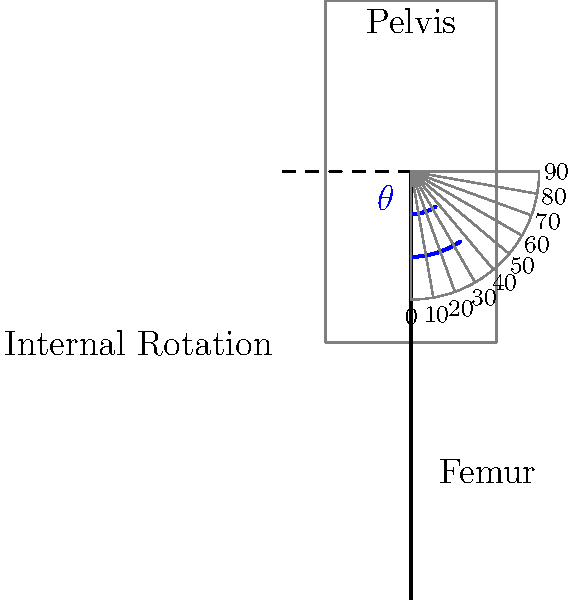In the skeletal diagram provided, the femur is shown internally rotated from its neutral position. Using the protractor overlay, determine the precise angle $\theta$ of hip internal rotation. What is the physiological significance of this measurement in assessing hip joint function and potential pathologies? To accurately measure the angle of hip internal rotation, we'll follow these steps:

1. Identify the neutral position: In a neutral hip position, the femur would be perpendicular to the transverse plane of the pelvis, which is represented by the horizontal dashed line.

2. Locate the current position: The solid line representing the femur shows its position after internal rotation.

3. Measure the angle: The angle $\theta$ is formed between the neutral position (dashed line) and the current position of the femur.

4. Use the protractor: The protractor overlay is centered at the hip joint. Count the tick marks from the neutral position (90° on the protractor) to the current femur position.

5. Calculate the angle: Each tick mark represents 10°. Counting from 90° to the femur's current position, we see it aligns with the 35° mark on the protractor.

6. Determine internal rotation: Since we're measuring from 90° (neutral) to 35°, the internal rotation angle is 90° - 35° = 55°.

Physiological significance:

a) Normal range: Hip internal rotation typically ranges from 30-40°. The measured 55° suggests hypermobility or potential joint laxity.

b) Joint assessment: Excessive internal rotation may indicate acetabular dysplasia, femoroacetabular impingement, or ligamentous laxity.

c) Muscle evaluation: Limited internal rotation could suggest tight external rotators (e.g., piriformis syndrome) or capsular restrictions.

d) Gait analysis: Internal rotation affects gait patterns and can contribute to various lower extremity issues if excessive or limited.

e) Osteoarthritis risk: Abnormal internal rotation angles are associated with increased risk of hip osteoarthritis development.

f) Sports medicine: Proper internal rotation is crucial for athletes, particularly in sports requiring quick direction changes or rotational movements.

g) Surgical planning: This measurement is vital for hip arthroplasty and other orthopedic procedures to ensure proper component positioning and joint mechanics.
Answer: 55°; excessive internal rotation (hypermobility) 